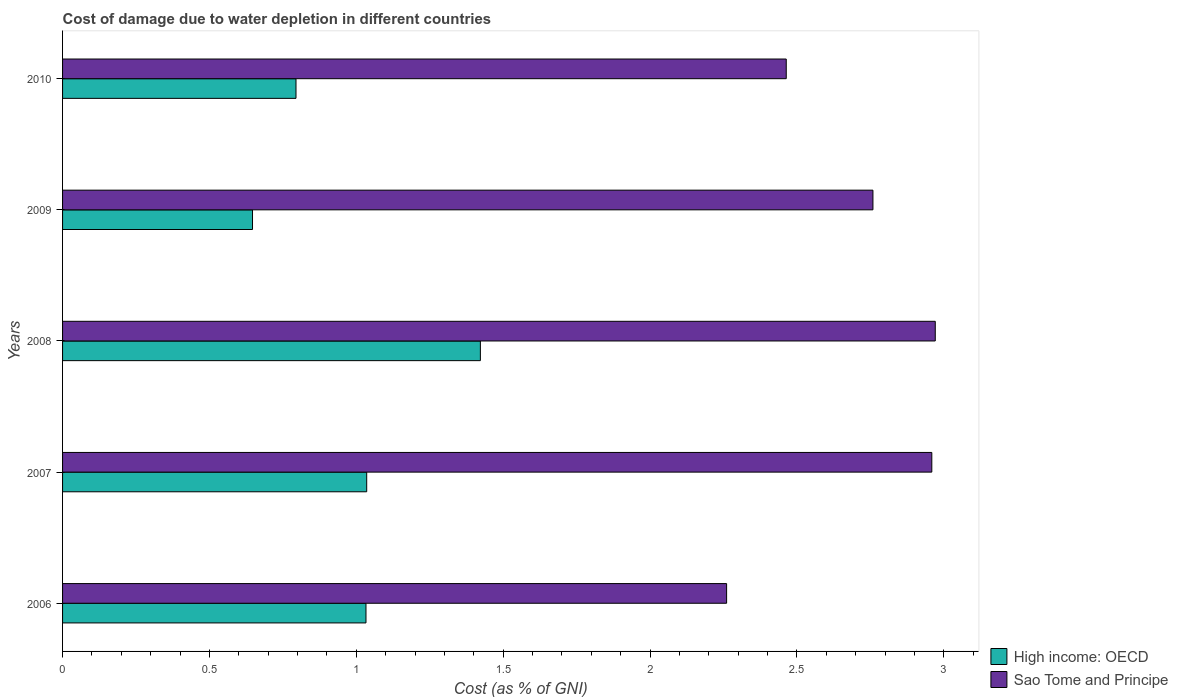How many different coloured bars are there?
Make the answer very short. 2. What is the label of the 2nd group of bars from the top?
Ensure brevity in your answer.  2009. In how many cases, is the number of bars for a given year not equal to the number of legend labels?
Make the answer very short. 0. What is the cost of damage caused due to water depletion in High income: OECD in 2010?
Your response must be concise. 0.79. Across all years, what is the maximum cost of damage caused due to water depletion in High income: OECD?
Keep it short and to the point. 1.42. Across all years, what is the minimum cost of damage caused due to water depletion in High income: OECD?
Offer a very short reply. 0.65. In which year was the cost of damage caused due to water depletion in Sao Tome and Principe maximum?
Make the answer very short. 2008. What is the total cost of damage caused due to water depletion in Sao Tome and Principe in the graph?
Your answer should be very brief. 13.41. What is the difference between the cost of damage caused due to water depletion in High income: OECD in 2006 and that in 2008?
Make the answer very short. -0.39. What is the difference between the cost of damage caused due to water depletion in High income: OECD in 2006 and the cost of damage caused due to water depletion in Sao Tome and Principe in 2009?
Make the answer very short. -1.73. What is the average cost of damage caused due to water depletion in Sao Tome and Principe per year?
Your answer should be very brief. 2.68. In the year 2009, what is the difference between the cost of damage caused due to water depletion in Sao Tome and Principe and cost of damage caused due to water depletion in High income: OECD?
Your answer should be very brief. 2.11. In how many years, is the cost of damage caused due to water depletion in Sao Tome and Principe greater than 0.4 %?
Your answer should be compact. 5. What is the ratio of the cost of damage caused due to water depletion in High income: OECD in 2009 to that in 2010?
Your answer should be very brief. 0.81. Is the cost of damage caused due to water depletion in High income: OECD in 2007 less than that in 2009?
Your answer should be very brief. No. What is the difference between the highest and the second highest cost of damage caused due to water depletion in Sao Tome and Principe?
Your answer should be compact. 0.01. What is the difference between the highest and the lowest cost of damage caused due to water depletion in Sao Tome and Principe?
Offer a terse response. 0.71. In how many years, is the cost of damage caused due to water depletion in Sao Tome and Principe greater than the average cost of damage caused due to water depletion in Sao Tome and Principe taken over all years?
Offer a terse response. 3. What does the 2nd bar from the top in 2008 represents?
Your response must be concise. High income: OECD. What does the 1st bar from the bottom in 2009 represents?
Your answer should be very brief. High income: OECD. How many bars are there?
Your answer should be compact. 10. What is the difference between two consecutive major ticks on the X-axis?
Offer a terse response. 0.5. Does the graph contain grids?
Provide a short and direct response. No. What is the title of the graph?
Make the answer very short. Cost of damage due to water depletion in different countries. Does "Panama" appear as one of the legend labels in the graph?
Your response must be concise. No. What is the label or title of the X-axis?
Offer a terse response. Cost (as % of GNI). What is the Cost (as % of GNI) in High income: OECD in 2006?
Keep it short and to the point. 1.03. What is the Cost (as % of GNI) in Sao Tome and Principe in 2006?
Give a very brief answer. 2.26. What is the Cost (as % of GNI) of High income: OECD in 2007?
Ensure brevity in your answer.  1.04. What is the Cost (as % of GNI) of Sao Tome and Principe in 2007?
Give a very brief answer. 2.96. What is the Cost (as % of GNI) of High income: OECD in 2008?
Provide a succinct answer. 1.42. What is the Cost (as % of GNI) of Sao Tome and Principe in 2008?
Your answer should be compact. 2.97. What is the Cost (as % of GNI) of High income: OECD in 2009?
Offer a terse response. 0.65. What is the Cost (as % of GNI) in Sao Tome and Principe in 2009?
Make the answer very short. 2.76. What is the Cost (as % of GNI) in High income: OECD in 2010?
Keep it short and to the point. 0.79. What is the Cost (as % of GNI) in Sao Tome and Principe in 2010?
Your response must be concise. 2.46. Across all years, what is the maximum Cost (as % of GNI) of High income: OECD?
Give a very brief answer. 1.42. Across all years, what is the maximum Cost (as % of GNI) in Sao Tome and Principe?
Your response must be concise. 2.97. Across all years, what is the minimum Cost (as % of GNI) of High income: OECD?
Keep it short and to the point. 0.65. Across all years, what is the minimum Cost (as % of GNI) of Sao Tome and Principe?
Your response must be concise. 2.26. What is the total Cost (as % of GNI) in High income: OECD in the graph?
Keep it short and to the point. 4.93. What is the total Cost (as % of GNI) of Sao Tome and Principe in the graph?
Provide a short and direct response. 13.41. What is the difference between the Cost (as % of GNI) in High income: OECD in 2006 and that in 2007?
Your response must be concise. -0. What is the difference between the Cost (as % of GNI) of Sao Tome and Principe in 2006 and that in 2007?
Ensure brevity in your answer.  -0.7. What is the difference between the Cost (as % of GNI) in High income: OECD in 2006 and that in 2008?
Offer a very short reply. -0.39. What is the difference between the Cost (as % of GNI) of Sao Tome and Principe in 2006 and that in 2008?
Keep it short and to the point. -0.71. What is the difference between the Cost (as % of GNI) in High income: OECD in 2006 and that in 2009?
Your answer should be compact. 0.39. What is the difference between the Cost (as % of GNI) in Sao Tome and Principe in 2006 and that in 2009?
Provide a succinct answer. -0.5. What is the difference between the Cost (as % of GNI) in High income: OECD in 2006 and that in 2010?
Your response must be concise. 0.24. What is the difference between the Cost (as % of GNI) of Sao Tome and Principe in 2006 and that in 2010?
Keep it short and to the point. -0.2. What is the difference between the Cost (as % of GNI) of High income: OECD in 2007 and that in 2008?
Provide a succinct answer. -0.39. What is the difference between the Cost (as % of GNI) in Sao Tome and Principe in 2007 and that in 2008?
Keep it short and to the point. -0.01. What is the difference between the Cost (as % of GNI) of High income: OECD in 2007 and that in 2009?
Make the answer very short. 0.39. What is the difference between the Cost (as % of GNI) of Sao Tome and Principe in 2007 and that in 2009?
Give a very brief answer. 0.2. What is the difference between the Cost (as % of GNI) in High income: OECD in 2007 and that in 2010?
Provide a succinct answer. 0.24. What is the difference between the Cost (as % of GNI) in Sao Tome and Principe in 2007 and that in 2010?
Ensure brevity in your answer.  0.5. What is the difference between the Cost (as % of GNI) in High income: OECD in 2008 and that in 2009?
Your answer should be very brief. 0.78. What is the difference between the Cost (as % of GNI) of Sao Tome and Principe in 2008 and that in 2009?
Offer a very short reply. 0.21. What is the difference between the Cost (as % of GNI) in High income: OECD in 2008 and that in 2010?
Your answer should be compact. 0.63. What is the difference between the Cost (as % of GNI) of Sao Tome and Principe in 2008 and that in 2010?
Offer a very short reply. 0.51. What is the difference between the Cost (as % of GNI) in High income: OECD in 2009 and that in 2010?
Make the answer very short. -0.15. What is the difference between the Cost (as % of GNI) of Sao Tome and Principe in 2009 and that in 2010?
Ensure brevity in your answer.  0.3. What is the difference between the Cost (as % of GNI) of High income: OECD in 2006 and the Cost (as % of GNI) of Sao Tome and Principe in 2007?
Your answer should be compact. -1.93. What is the difference between the Cost (as % of GNI) of High income: OECD in 2006 and the Cost (as % of GNI) of Sao Tome and Principe in 2008?
Your answer should be compact. -1.94. What is the difference between the Cost (as % of GNI) in High income: OECD in 2006 and the Cost (as % of GNI) in Sao Tome and Principe in 2009?
Give a very brief answer. -1.73. What is the difference between the Cost (as % of GNI) of High income: OECD in 2006 and the Cost (as % of GNI) of Sao Tome and Principe in 2010?
Ensure brevity in your answer.  -1.43. What is the difference between the Cost (as % of GNI) in High income: OECD in 2007 and the Cost (as % of GNI) in Sao Tome and Principe in 2008?
Make the answer very short. -1.94. What is the difference between the Cost (as % of GNI) in High income: OECD in 2007 and the Cost (as % of GNI) in Sao Tome and Principe in 2009?
Keep it short and to the point. -1.72. What is the difference between the Cost (as % of GNI) in High income: OECD in 2007 and the Cost (as % of GNI) in Sao Tome and Principe in 2010?
Provide a short and direct response. -1.43. What is the difference between the Cost (as % of GNI) of High income: OECD in 2008 and the Cost (as % of GNI) of Sao Tome and Principe in 2009?
Your response must be concise. -1.34. What is the difference between the Cost (as % of GNI) of High income: OECD in 2008 and the Cost (as % of GNI) of Sao Tome and Principe in 2010?
Your response must be concise. -1.04. What is the difference between the Cost (as % of GNI) of High income: OECD in 2009 and the Cost (as % of GNI) of Sao Tome and Principe in 2010?
Make the answer very short. -1.82. What is the average Cost (as % of GNI) of High income: OECD per year?
Your response must be concise. 0.99. What is the average Cost (as % of GNI) of Sao Tome and Principe per year?
Ensure brevity in your answer.  2.68. In the year 2006, what is the difference between the Cost (as % of GNI) of High income: OECD and Cost (as % of GNI) of Sao Tome and Principe?
Your response must be concise. -1.23. In the year 2007, what is the difference between the Cost (as % of GNI) of High income: OECD and Cost (as % of GNI) of Sao Tome and Principe?
Provide a short and direct response. -1.92. In the year 2008, what is the difference between the Cost (as % of GNI) in High income: OECD and Cost (as % of GNI) in Sao Tome and Principe?
Your answer should be compact. -1.55. In the year 2009, what is the difference between the Cost (as % of GNI) in High income: OECD and Cost (as % of GNI) in Sao Tome and Principe?
Offer a very short reply. -2.11. In the year 2010, what is the difference between the Cost (as % of GNI) of High income: OECD and Cost (as % of GNI) of Sao Tome and Principe?
Give a very brief answer. -1.67. What is the ratio of the Cost (as % of GNI) of Sao Tome and Principe in 2006 to that in 2007?
Your answer should be compact. 0.76. What is the ratio of the Cost (as % of GNI) of High income: OECD in 2006 to that in 2008?
Your response must be concise. 0.73. What is the ratio of the Cost (as % of GNI) of Sao Tome and Principe in 2006 to that in 2008?
Offer a very short reply. 0.76. What is the ratio of the Cost (as % of GNI) of High income: OECD in 2006 to that in 2009?
Make the answer very short. 1.6. What is the ratio of the Cost (as % of GNI) of Sao Tome and Principe in 2006 to that in 2009?
Ensure brevity in your answer.  0.82. What is the ratio of the Cost (as % of GNI) of High income: OECD in 2006 to that in 2010?
Your response must be concise. 1.3. What is the ratio of the Cost (as % of GNI) in Sao Tome and Principe in 2006 to that in 2010?
Offer a terse response. 0.92. What is the ratio of the Cost (as % of GNI) of High income: OECD in 2007 to that in 2008?
Your answer should be compact. 0.73. What is the ratio of the Cost (as % of GNI) in Sao Tome and Principe in 2007 to that in 2008?
Provide a short and direct response. 1. What is the ratio of the Cost (as % of GNI) in High income: OECD in 2007 to that in 2009?
Your answer should be compact. 1.6. What is the ratio of the Cost (as % of GNI) in Sao Tome and Principe in 2007 to that in 2009?
Ensure brevity in your answer.  1.07. What is the ratio of the Cost (as % of GNI) of High income: OECD in 2007 to that in 2010?
Ensure brevity in your answer.  1.3. What is the ratio of the Cost (as % of GNI) in Sao Tome and Principe in 2007 to that in 2010?
Offer a very short reply. 1.2. What is the ratio of the Cost (as % of GNI) in High income: OECD in 2008 to that in 2009?
Provide a short and direct response. 2.2. What is the ratio of the Cost (as % of GNI) in Sao Tome and Principe in 2008 to that in 2009?
Offer a very short reply. 1.08. What is the ratio of the Cost (as % of GNI) in High income: OECD in 2008 to that in 2010?
Make the answer very short. 1.79. What is the ratio of the Cost (as % of GNI) in Sao Tome and Principe in 2008 to that in 2010?
Offer a terse response. 1.21. What is the ratio of the Cost (as % of GNI) in High income: OECD in 2009 to that in 2010?
Provide a short and direct response. 0.81. What is the ratio of the Cost (as % of GNI) in Sao Tome and Principe in 2009 to that in 2010?
Your response must be concise. 1.12. What is the difference between the highest and the second highest Cost (as % of GNI) in High income: OECD?
Offer a terse response. 0.39. What is the difference between the highest and the second highest Cost (as % of GNI) of Sao Tome and Principe?
Your response must be concise. 0.01. What is the difference between the highest and the lowest Cost (as % of GNI) in High income: OECD?
Give a very brief answer. 0.78. What is the difference between the highest and the lowest Cost (as % of GNI) of Sao Tome and Principe?
Offer a terse response. 0.71. 